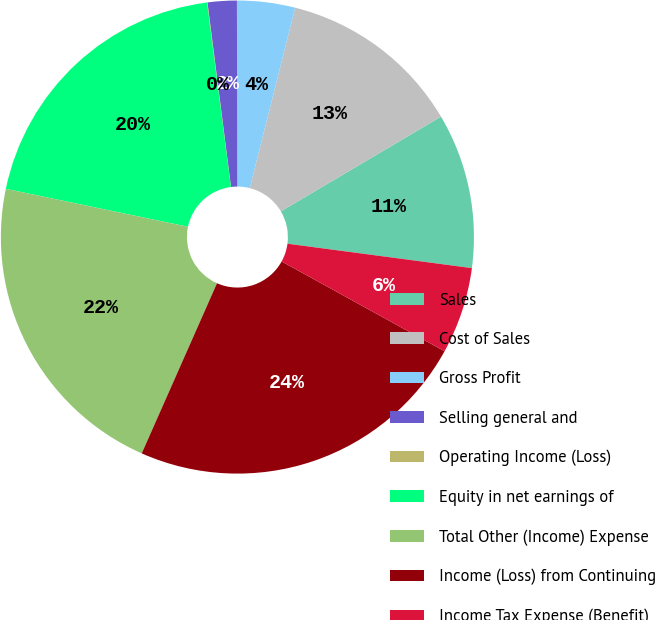<chart> <loc_0><loc_0><loc_500><loc_500><pie_chart><fcel>Sales<fcel>Cost of Sales<fcel>Gross Profit<fcel>Selling general and<fcel>Operating Income (Loss)<fcel>Equity in net earnings of<fcel>Total Other (Income) Expense<fcel>Income (Loss) from Continuing<fcel>Income Tax Expense (Benefit)<nl><fcel>10.6%<fcel>12.57%<fcel>3.96%<fcel>1.99%<fcel>0.03%<fcel>19.68%<fcel>21.64%<fcel>23.61%<fcel>5.92%<nl></chart> 